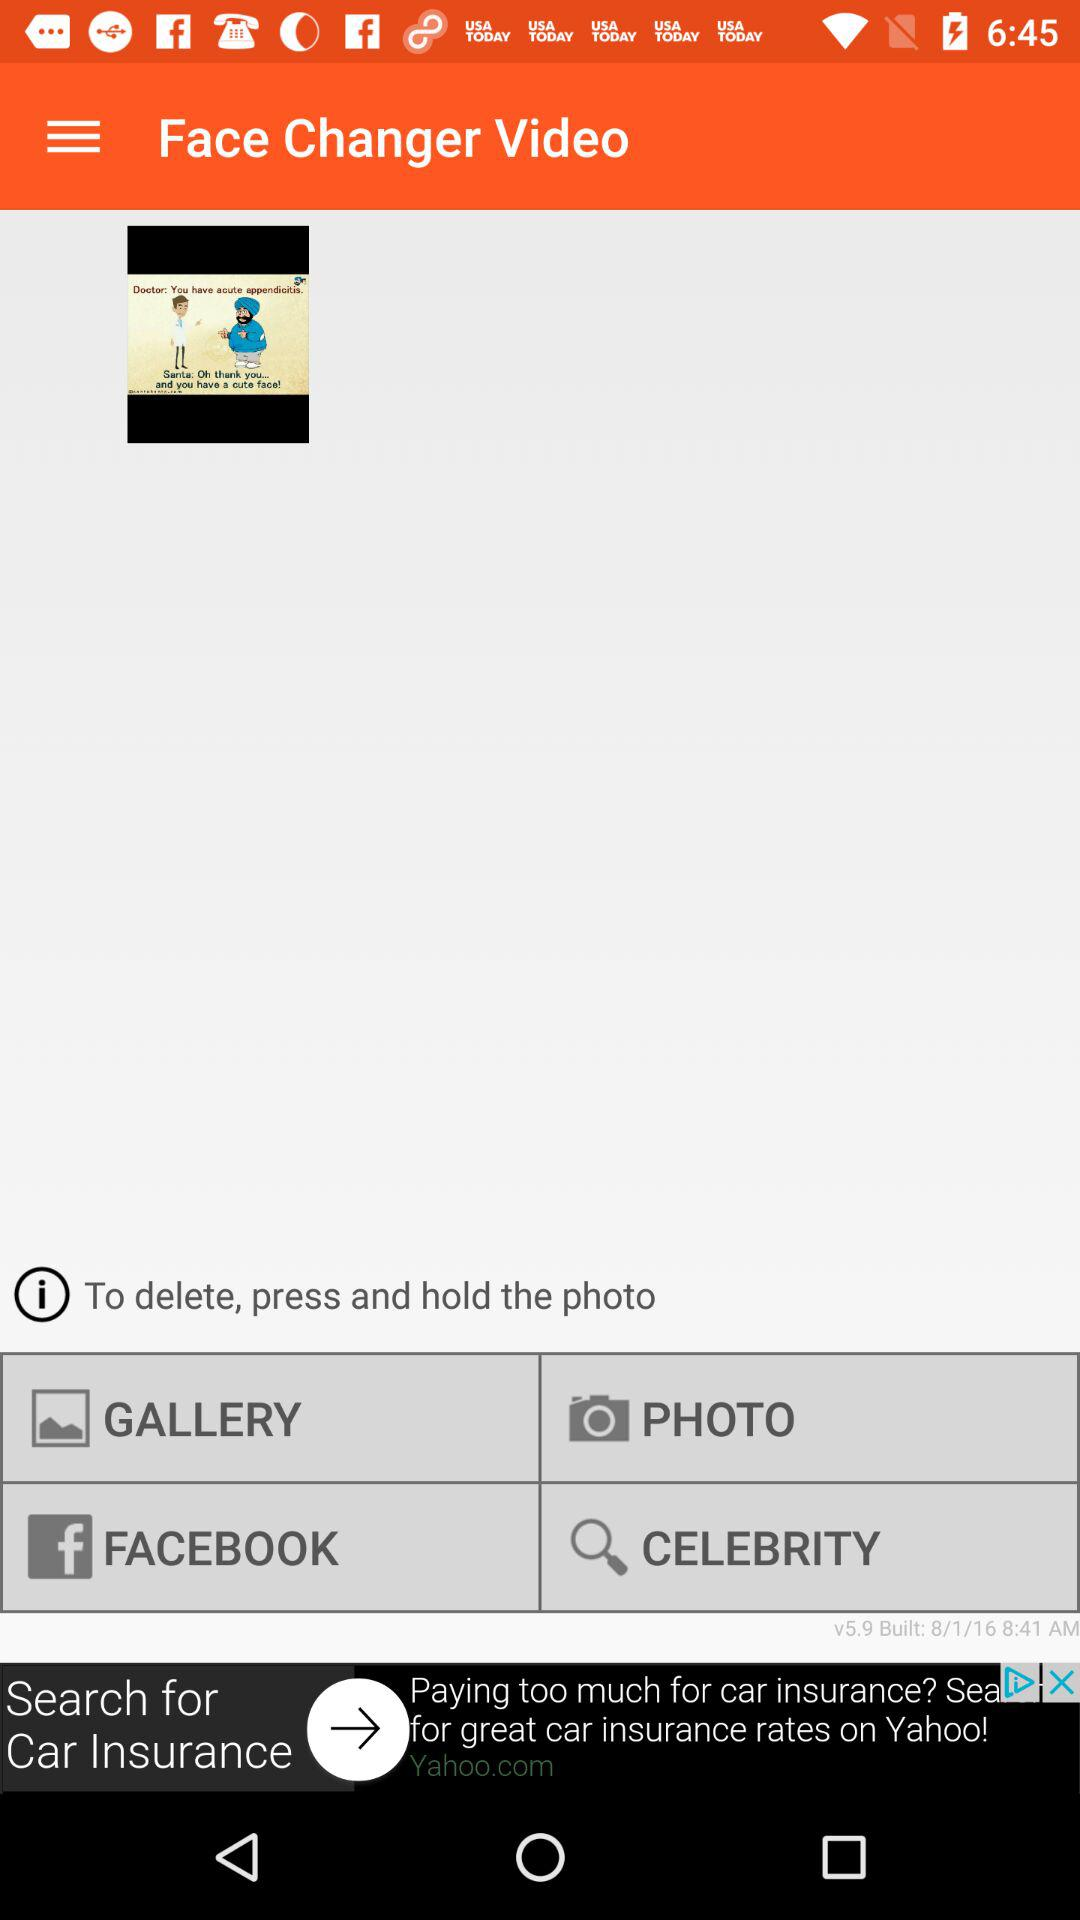What is the application name? The application name is "Face Changer Video". 